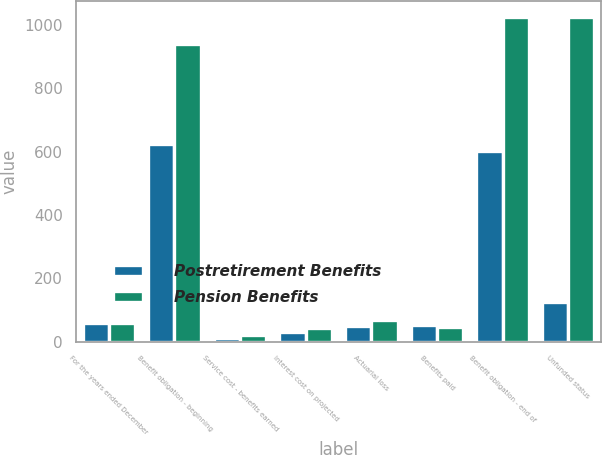<chart> <loc_0><loc_0><loc_500><loc_500><stacked_bar_chart><ecel><fcel>For the years ended December<fcel>Benefit obligation - beginning<fcel>Service cost - benefits earned<fcel>Interest cost on projected<fcel>Actuarial loss<fcel>Benefits paid<fcel>Benefit obligation - end of<fcel>Unfunded status<nl><fcel>Postretirement Benefits<fcel>59<fcel>624<fcel>12<fcel>29<fcel>49<fcel>51<fcel>601<fcel>125<nl><fcel>Pension Benefits<fcel>59<fcel>940<fcel>21<fcel>43<fcel>67<fcel>46<fcel>1025<fcel>1025<nl></chart> 